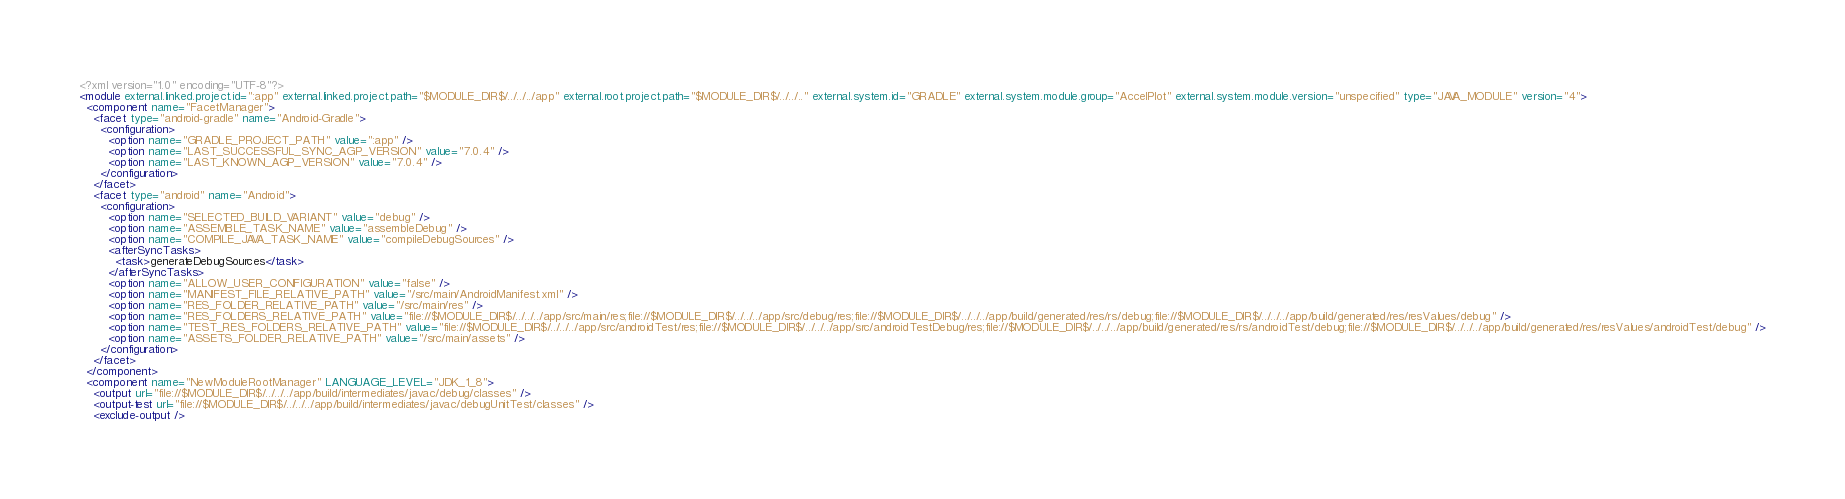<code> <loc_0><loc_0><loc_500><loc_500><_XML_><?xml version="1.0" encoding="UTF-8"?>
<module external.linked.project.id=":app" external.linked.project.path="$MODULE_DIR$/../../../app" external.root.project.path="$MODULE_DIR$/../../.." external.system.id="GRADLE" external.system.module.group="AccelPlot" external.system.module.version="unspecified" type="JAVA_MODULE" version="4">
  <component name="FacetManager">
    <facet type="android-gradle" name="Android-Gradle">
      <configuration>
        <option name="GRADLE_PROJECT_PATH" value=":app" />
        <option name="LAST_SUCCESSFUL_SYNC_AGP_VERSION" value="7.0.4" />
        <option name="LAST_KNOWN_AGP_VERSION" value="7.0.4" />
      </configuration>
    </facet>
    <facet type="android" name="Android">
      <configuration>
        <option name="SELECTED_BUILD_VARIANT" value="debug" />
        <option name="ASSEMBLE_TASK_NAME" value="assembleDebug" />
        <option name="COMPILE_JAVA_TASK_NAME" value="compileDebugSources" />
        <afterSyncTasks>
          <task>generateDebugSources</task>
        </afterSyncTasks>
        <option name="ALLOW_USER_CONFIGURATION" value="false" />
        <option name="MANIFEST_FILE_RELATIVE_PATH" value="/src/main/AndroidManifest.xml" />
        <option name="RES_FOLDER_RELATIVE_PATH" value="/src/main/res" />
        <option name="RES_FOLDERS_RELATIVE_PATH" value="file://$MODULE_DIR$/../../../app/src/main/res;file://$MODULE_DIR$/../../../app/src/debug/res;file://$MODULE_DIR$/../../../app/build/generated/res/rs/debug;file://$MODULE_DIR$/../../../app/build/generated/res/resValues/debug" />
        <option name="TEST_RES_FOLDERS_RELATIVE_PATH" value="file://$MODULE_DIR$/../../../app/src/androidTest/res;file://$MODULE_DIR$/../../../app/src/androidTestDebug/res;file://$MODULE_DIR$/../../../app/build/generated/res/rs/androidTest/debug;file://$MODULE_DIR$/../../../app/build/generated/res/resValues/androidTest/debug" />
        <option name="ASSETS_FOLDER_RELATIVE_PATH" value="/src/main/assets" />
      </configuration>
    </facet>
  </component>
  <component name="NewModuleRootManager" LANGUAGE_LEVEL="JDK_1_8">
    <output url="file://$MODULE_DIR$/../../../app/build/intermediates/javac/debug/classes" />
    <output-test url="file://$MODULE_DIR$/../../../app/build/intermediates/javac/debugUnitTest/classes" />
    <exclude-output /></code> 